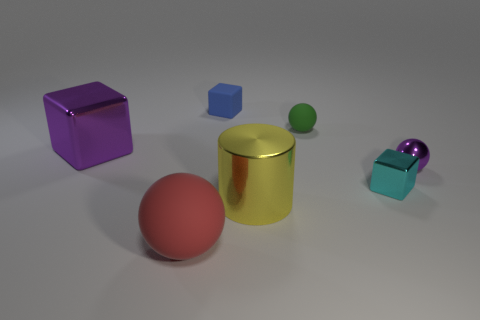There is a sphere that is the same color as the big cube; what size is it?
Provide a succinct answer. Small. There is a metallic object that is in front of the tiny shiny cube; is it the same color as the sphere in front of the purple metallic ball?
Ensure brevity in your answer.  No. The green matte sphere has what size?
Ensure brevity in your answer.  Small. What number of large things are either purple metallic objects or yellow metallic spheres?
Offer a very short reply. 1. What is the color of the matte thing that is the same size as the green ball?
Your response must be concise. Blue. What number of other things are the same shape as the small blue rubber object?
Provide a short and direct response. 2. Is there another cylinder made of the same material as the large yellow cylinder?
Offer a very short reply. No. Does the tiny block in front of the small green rubber sphere have the same material as the purple thing on the right side of the big yellow shiny thing?
Provide a short and direct response. Yes. What number of matte spheres are there?
Keep it short and to the point. 2. What is the shape of the metallic object that is to the left of the large yellow metal thing?
Provide a succinct answer. Cube. 